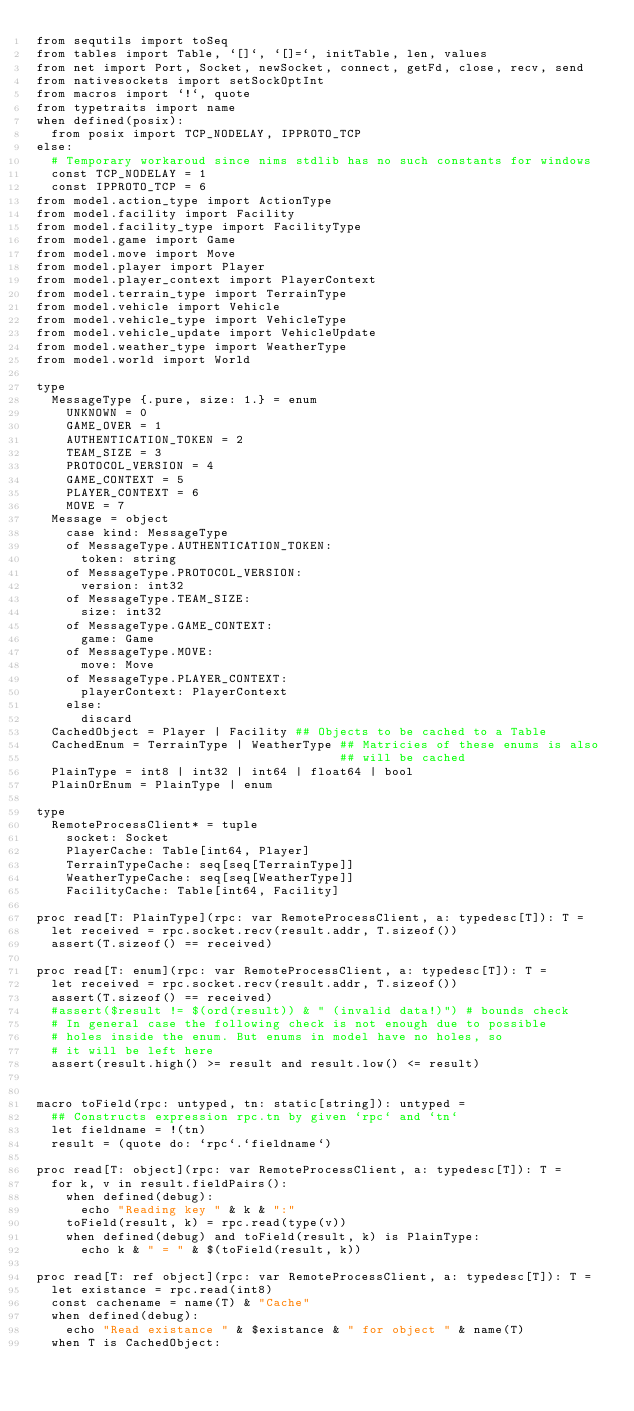<code> <loc_0><loc_0><loc_500><loc_500><_Nim_>from sequtils import toSeq
from tables import Table, `[]`, `[]=`, initTable, len, values
from net import Port, Socket, newSocket, connect, getFd, close, recv, send
from nativesockets import setSockOptInt
from macros import `!`, quote
from typetraits import name
when defined(posix):
  from posix import TCP_NODELAY, IPPROTO_TCP
else:
  # Temporary workaroud since nims stdlib has no such constants for windows
  const TCP_NODELAY = 1
  const IPPROTO_TCP = 6
from model.action_type import ActionType
from model.facility import Facility
from model.facility_type import FacilityType
from model.game import Game
from model.move import Move
from model.player import Player
from model.player_context import PlayerContext
from model.terrain_type import TerrainType
from model.vehicle import Vehicle
from model.vehicle_type import VehicleType
from model.vehicle_update import VehicleUpdate
from model.weather_type import WeatherType
from model.world import World

type
  MessageType {.pure, size: 1.} = enum
    UNKNOWN = 0
    GAME_OVER = 1
    AUTHENTICATION_TOKEN = 2
    TEAM_SIZE = 3
    PROTOCOL_VERSION = 4
    GAME_CONTEXT = 5
    PLAYER_CONTEXT = 6
    MOVE = 7
  Message = object
    case kind: MessageType
    of MessageType.AUTHENTICATION_TOKEN:
      token: string
    of MessageType.PROTOCOL_VERSION:
      version: int32
    of MessageType.TEAM_SIZE:
      size: int32
    of MessageType.GAME_CONTEXT:
      game: Game
    of MessageType.MOVE:
      move: Move
    of MessageType.PLAYER_CONTEXT:
      playerContext: PlayerContext
    else:
      discard
  CachedObject = Player | Facility ## Objects to be cached to a Table
  CachedEnum = TerrainType | WeatherType ## Matricies of these enums is also
                                         ## will be cached
  PlainType = int8 | int32 | int64 | float64 | bool
  PlainOrEnum = PlainType | enum

type
  RemoteProcessClient* = tuple
    socket: Socket
    PlayerCache: Table[int64, Player]
    TerrainTypeCache: seq[seq[TerrainType]]
    WeatherTypeCache: seq[seq[WeatherType]]
    FacilityCache: Table[int64, Facility]

proc read[T: PlainType](rpc: var RemoteProcessClient, a: typedesc[T]): T =
  let received = rpc.socket.recv(result.addr, T.sizeof())
  assert(T.sizeof() == received)

proc read[T: enum](rpc: var RemoteProcessClient, a: typedesc[T]): T =
  let received = rpc.socket.recv(result.addr, T.sizeof())
  assert(T.sizeof() == received)
  #assert($result != $(ord(result)) & " (invalid data!)") # bounds check
  # In general case the following check is not enough due to possible
  # holes inside the enum. But enums in model have no holes, so
  # it will be left here
  assert(result.high() >= result and result.low() <= result)


macro toField(rpc: untyped, tn: static[string]): untyped =
  ## Constructs expression rpc.tn by given `rpc` and `tn`
  let fieldname = !(tn)
  result = (quote do: `rpc`.`fieldname`)

proc read[T: object](rpc: var RemoteProcessClient, a: typedesc[T]): T =
  for k, v in result.fieldPairs():
    when defined(debug):
      echo "Reading key " & k & ":"
    toField(result, k) = rpc.read(type(v))
    when defined(debug) and toField(result, k) is PlainType:
      echo k & " = " & $(toField(result, k))

proc read[T: ref object](rpc: var RemoteProcessClient, a: typedesc[T]): T =
  let existance = rpc.read(int8)
  const cachename = name(T) & "Cache"
  when defined(debug):
    echo "Read existance " & $existance & " for object " & name(T)
  when T is CachedObject:</code> 